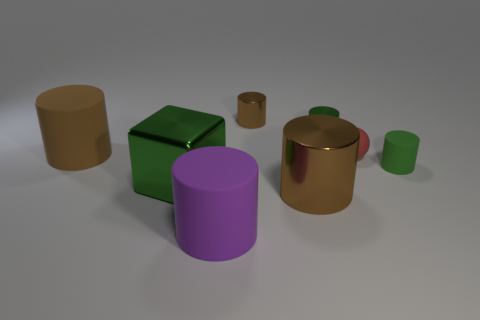Subtract all gray balls. How many brown cylinders are left? 3 Subtract all purple cylinders. How many cylinders are left? 5 Subtract all big brown matte cylinders. How many cylinders are left? 5 Subtract all red cylinders. Subtract all gray blocks. How many cylinders are left? 6 Add 1 tiny green objects. How many objects exist? 9 Subtract all balls. How many objects are left? 7 Subtract 0 brown balls. How many objects are left? 8 Subtract all large green rubber objects. Subtract all cylinders. How many objects are left? 2 Add 2 big purple things. How many big purple things are left? 3 Add 7 tiny yellow rubber spheres. How many tiny yellow rubber spheres exist? 7 